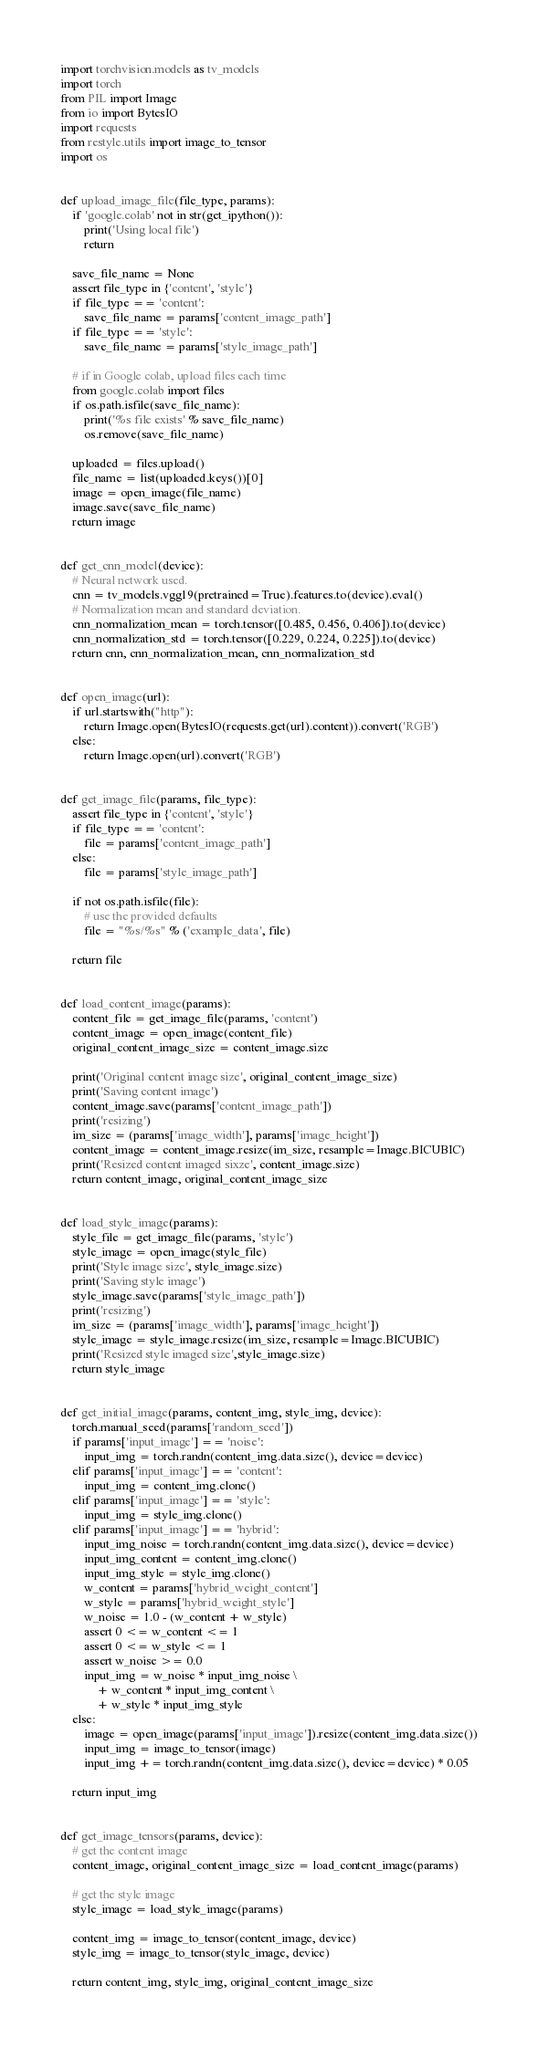Convert code to text. <code><loc_0><loc_0><loc_500><loc_500><_Python_>import torchvision.models as tv_models
import torch
from PIL import Image
from io import BytesIO
import requests
from restyle.utils import image_to_tensor
import os


def upload_image_file(file_type, params):
    if 'google.colab' not in str(get_ipython()):
        print('Using local file')
        return

    save_file_name = None
    assert file_type in {'content', 'style'}
    if file_type == 'content':
        save_file_name = params['content_image_path']
    if file_type == 'style':
        save_file_name = params['style_image_path']

    # if in Google colab, upload files each time
    from google.colab import files
    if os.path.isfile(save_file_name):
        print('%s file exists' % save_file_name)
        os.remove(save_file_name)

    uploaded = files.upload()
    file_name = list(uploaded.keys())[0]
    image = open_image(file_name)
    image.save(save_file_name)
    return image


def get_cnn_model(device):
    # Neural network used.
    cnn = tv_models.vgg19(pretrained=True).features.to(device).eval()
    # Normalization mean and standard deviation.
    cnn_normalization_mean = torch.tensor([0.485, 0.456, 0.406]).to(device)
    cnn_normalization_std = torch.tensor([0.229, 0.224, 0.225]).to(device)
    return cnn, cnn_normalization_mean, cnn_normalization_std


def open_image(url):
    if url.startswith("http"):
        return Image.open(BytesIO(requests.get(url).content)).convert('RGB')
    else:
        return Image.open(url).convert('RGB')


def get_image_file(params, file_type):
    assert file_type in {'content', 'style'}
    if file_type == 'content':
        file = params['content_image_path']
    else:
        file = params['style_image_path']

    if not os.path.isfile(file):
        # use the provided defaults
        file = "%s/%s" % ('example_data', file)

    return file


def load_content_image(params):
    content_file = get_image_file(params, 'content')
    content_image = open_image(content_file)
    original_content_image_size = content_image.size

    print('Original content image size', original_content_image_size)
    print('Saving content image')
    content_image.save(params['content_image_path'])
    print('resizing')
    im_size = (params['image_width'], params['image_height'])
    content_image = content_image.resize(im_size, resample=Image.BICUBIC)
    print('Resized content imaged sixze', content_image.size)
    return content_image, original_content_image_size


def load_style_image(params):
    style_file = get_image_file(params, 'style')
    style_image = open_image(style_file)
    print('Style image size', style_image.size)
    print('Saving style image')
    style_image.save(params['style_image_path'])
    print('resizing')
    im_size = (params['image_width'], params['image_height'])
    style_image = style_image.resize(im_size, resample=Image.BICUBIC)
    print('Resized style imaged size',style_image.size)
    return style_image


def get_initial_image(params, content_img, style_img, device):
    torch.manual_seed(params['random_seed'])
    if params['input_image'] == 'noise':
        input_img = torch.randn(content_img.data.size(), device=device)
    elif params['input_image'] == 'content':
        input_img = content_img.clone()
    elif params['input_image'] == 'style':
        input_img = style_img.clone()
    elif params['input_image'] == 'hybrid':
        input_img_noise = torch.randn(content_img.data.size(), device=device)
        input_img_content = content_img.clone()
        input_img_style = style_img.clone()
        w_content = params['hybrid_weight_content']
        w_style = params['hybrid_weight_style']
        w_noise = 1.0 - (w_content + w_style)
        assert 0 <= w_content <= 1
        assert 0 <= w_style <= 1
        assert w_noise >= 0.0
        input_img = w_noise * input_img_noise \
            + w_content * input_img_content \
            + w_style * input_img_style
    else:
        image = open_image(params['input_image']).resize(content_img.data.size())
        input_img = image_to_tensor(image)
        input_img += torch.randn(content_img.data.size(), device=device) * 0.05

    return input_img


def get_image_tensors(params, device):
    # get the content image
    content_image, original_content_image_size = load_content_image(params)

    # get the style image
    style_image = load_style_image(params)

    content_img = image_to_tensor(content_image, device)
    style_img = image_to_tensor(style_image, device)

    return content_img, style_img, original_content_image_size
</code> 